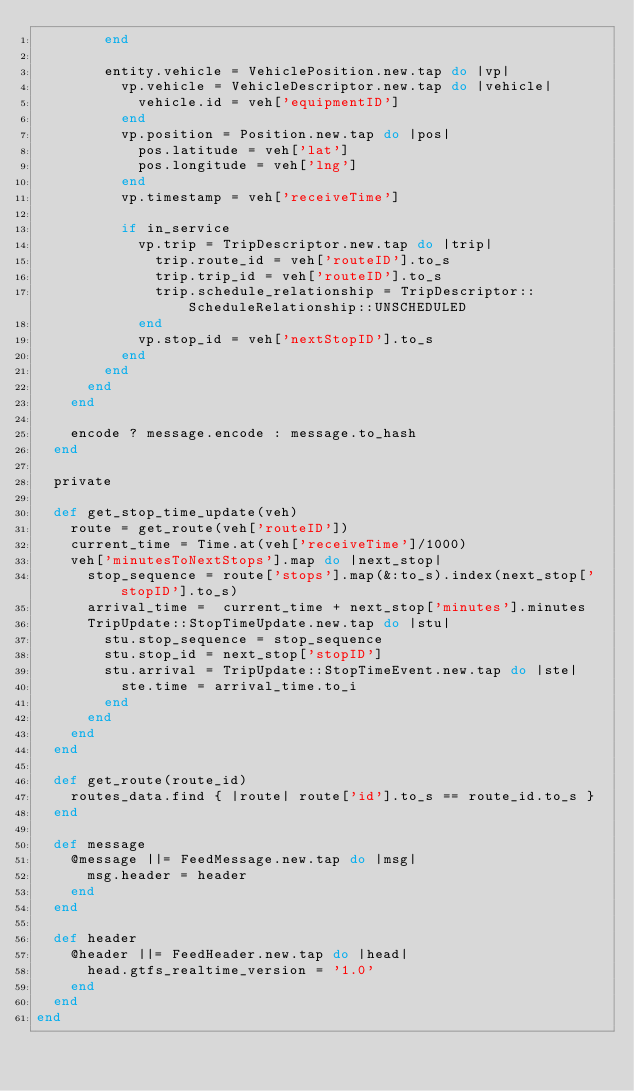Convert code to text. <code><loc_0><loc_0><loc_500><loc_500><_Ruby_>        end

        entity.vehicle = VehiclePosition.new.tap do |vp|
          vp.vehicle = VehicleDescriptor.new.tap do |vehicle|
            vehicle.id = veh['equipmentID']
          end
          vp.position = Position.new.tap do |pos|
            pos.latitude = veh['lat']
            pos.longitude = veh['lng']
          end
          vp.timestamp = veh['receiveTime']

          if in_service
            vp.trip = TripDescriptor.new.tap do |trip|
              trip.route_id = veh['routeID'].to_s
              trip.trip_id = veh['routeID'].to_s
              trip.schedule_relationship = TripDescriptor::ScheduleRelationship::UNSCHEDULED
            end
            vp.stop_id = veh['nextStopID'].to_s
          end
        end
      end
    end

    encode ? message.encode : message.to_hash
  end

  private

  def get_stop_time_update(veh)
    route = get_route(veh['routeID'])
    current_time = Time.at(veh['receiveTime']/1000)
    veh['minutesToNextStops'].map do |next_stop|
      stop_sequence = route['stops'].map(&:to_s).index(next_stop['stopID'].to_s)
      arrival_time =  current_time + next_stop['minutes'].minutes
      TripUpdate::StopTimeUpdate.new.tap do |stu|
        stu.stop_sequence = stop_sequence
        stu.stop_id = next_stop['stopID']
        stu.arrival = TripUpdate::StopTimeEvent.new.tap do |ste|
          ste.time = arrival_time.to_i
        end
      end
    end
  end

  def get_route(route_id)
    routes_data.find { |route| route['id'].to_s == route_id.to_s }
  end

  def message
    @message ||= FeedMessage.new.tap do |msg|
      msg.header = header
    end
  end

  def header
    @header ||= FeedHeader.new.tap do |head|
      head.gtfs_realtime_version = '1.0'
    end
  end
end
</code> 